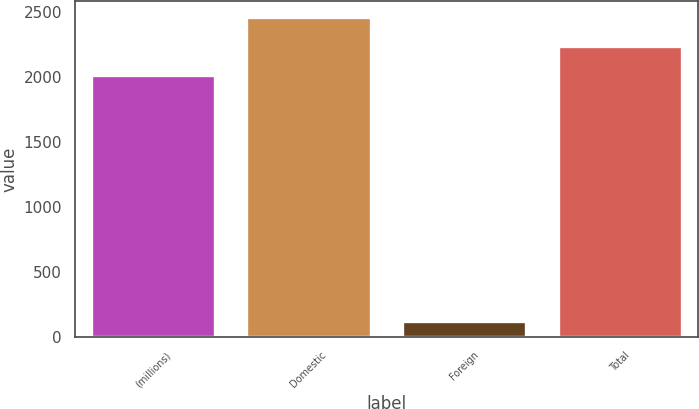Convert chart. <chart><loc_0><loc_0><loc_500><loc_500><bar_chart><fcel>(millions)<fcel>Domestic<fcel>Foreign<fcel>Total<nl><fcel>2015<fcel>2458.8<fcel>119<fcel>2236.9<nl></chart> 